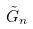<formula> <loc_0><loc_0><loc_500><loc_500>\tilde { G } _ { n }</formula> 